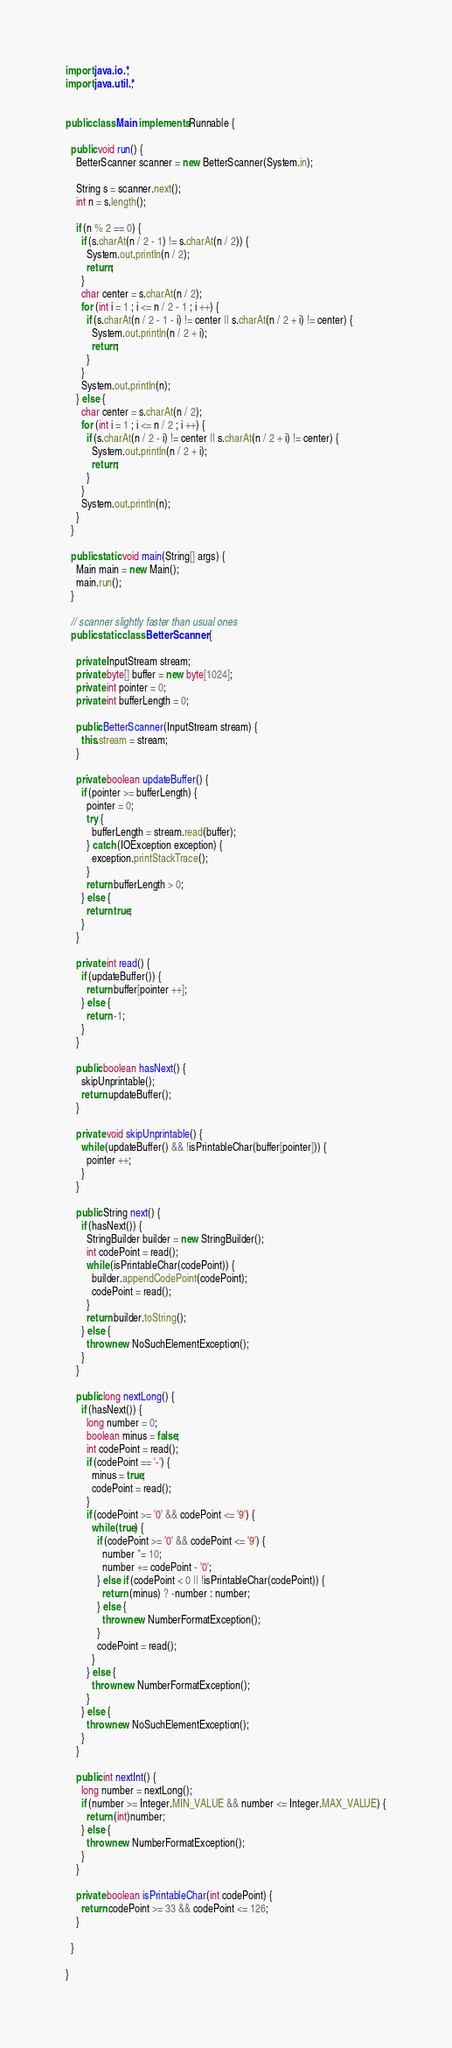Convert code to text. <code><loc_0><loc_0><loc_500><loc_500><_Java_>import java.io.*;
import java.util.*;
 
 
public class Main implements Runnable {
 
  public void run() {
    BetterScanner scanner = new BetterScanner(System.in);
  
    String s = scanner.next();
    int n = s.length();

    if (n % 2 == 0) {
      if (s.charAt(n / 2 - 1) != s.charAt(n / 2)) {
        System.out.println(n / 2);
        return;
      }
      char center = s.charAt(n / 2);
      for (int i = 1 ; i <= n / 2 - 1 ; i ++) {
        if (s.charAt(n / 2 - 1 - i) != center || s.charAt(n / 2 + i) != center) {
          System.out.println(n / 2 + i);
          return;
        }
      }
      System.out.println(n);
    } else {
      char center = s.charAt(n / 2);
      for (int i = 1 ; i <= n / 2 ; i ++) {
        if (s.charAt(n / 2 - i) != center || s.charAt(n / 2 + i) != center) {
          System.out.println(n / 2 + i);
          return;
        }
      }
      System.out.println(n);
    }
  }
 
  public static void main(String[] args) {
    Main main = new Main();
    main.run();
  }
 
  // scanner slightly faster than usual ones
  public static class BetterScanner {
 
    private InputStream stream;
    private byte[] buffer = new byte[1024];
    private int pointer = 0;
    private int bufferLength = 0;
 
    public BetterScanner(InputStream stream) {
      this.stream = stream;
    }
 
    private boolean updateBuffer() {
      if (pointer >= bufferLength) {
        pointer = 0;
        try {
          bufferLength = stream.read(buffer);
        } catch (IOException exception) {
          exception.printStackTrace();
        }
        return bufferLength > 0;
      } else {
        return true;
      }
    }
 
    private int read() {
      if (updateBuffer()) {
        return buffer[pointer ++];
      } else {
        return -1;
      }
    }
 
    public boolean hasNext() {
      skipUnprintable();
      return updateBuffer();
    }
 
    private void skipUnprintable() { 
      while (updateBuffer() && !isPrintableChar(buffer[pointer])) {
        pointer ++;
      }
    }
 
    public String next() {
      if (hasNext()) {
        StringBuilder builder = new StringBuilder();
        int codePoint = read();
        while (isPrintableChar(codePoint)) {
          builder.appendCodePoint(codePoint);
          codePoint = read();
        }
        return builder.toString();
      } else {
        throw new NoSuchElementException();
      }
    }
 
    public long nextLong() {
      if (hasNext()) {
        long number = 0;
        boolean minus = false;
        int codePoint = read();
        if (codePoint == '-') {
          minus = true;
          codePoint = read();
        }
        if (codePoint >= '0' && codePoint <= '9') {
          while (true) {
            if (codePoint >= '0' && codePoint <= '9') {
              number *= 10;
              number += codePoint - '0';
            } else if (codePoint < 0 || !isPrintableChar(codePoint)) {
              return (minus) ? -number : number;
            } else {
              throw new NumberFormatException();
            }
            codePoint = read();
          }
        } else {
          throw new NumberFormatException();
        }
      } else {
        throw new NoSuchElementException();
      }
    }
 
    public int nextInt() {
      long number = nextLong();
      if (number >= Integer.MIN_VALUE && number <= Integer.MAX_VALUE) {
        return (int)number;
      } else {
        throw new NumberFormatException();
      }
    }
 
    private boolean isPrintableChar(int codePoint) {
      return codePoint >= 33 && codePoint <= 126;
    }
 
  }
 
}</code> 